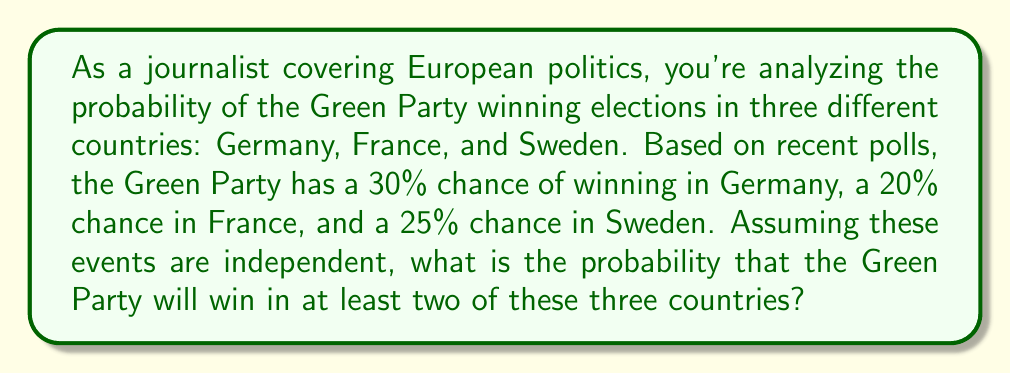Show me your answer to this math problem. To solve this problem, we need to use the concept of probability for independent events and the complement rule.

Let's break it down step by step:

1) First, let's define our events:
   $G$ = Green Party wins in Germany
   $F$ = Green Party wins in France
   $S$ = Green Party wins in Sweden

2) Given probabilities:
   $P(G) = 0.30$
   $P(F) = 0.20$
   $P(S) = 0.25$

3) We need to find the probability of winning in at least two countries. It's easier to calculate the complement of this event (winning in one or zero countries) and then subtract from 1.

4) Probability of not winning:
   $P(\text{not }G) = 1 - 0.30 = 0.70$
   $P(\text{not }F) = 1 - 0.20 = 0.80$
   $P(\text{not }S) = 1 - 0.25 = 0.75$

5) Probability of winning in zero countries:
   $P(\text{zero wins}) = 0.70 \times 0.80 \times 0.75 = 0.42$

6) Probability of winning in exactly one country:
   $P(\text{only }G) = 0.30 \times 0.80 \times 0.75 = 0.18$
   $P(\text{only }F) = 0.70 \times 0.20 \times 0.75 = 0.105$
   $P(\text{only }S) = 0.70 \times 0.80 \times 0.25 = 0.14$
   
   $P(\text{one win}) = 0.18 + 0.105 + 0.14 = 0.425$

7) Probability of winning in zero or one country:
   $P(\text{zero or one win}) = 0.42 + 0.425 = 0.845$

8) Therefore, the probability of winning in at least two countries:
   $P(\text{at least two wins}) = 1 - P(\text{zero or one win}) = 1 - 0.845 = 0.155$
Answer: The probability that the Green Party will win in at least two of the three countries is $0.155$ or $15.5\%$. 